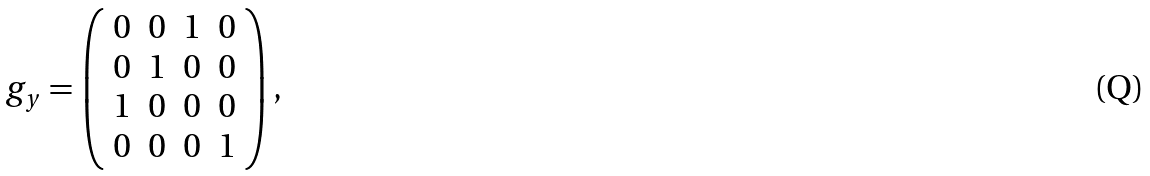Convert formula to latex. <formula><loc_0><loc_0><loc_500><loc_500>g _ { y } = \left ( \begin{array} { c c c c } 0 & 0 & 1 & 0 \\ 0 & 1 & 0 & 0 \\ 1 & 0 & 0 & 0 \\ 0 & 0 & 0 & 1 \\ \end{array} \right ) ,</formula> 